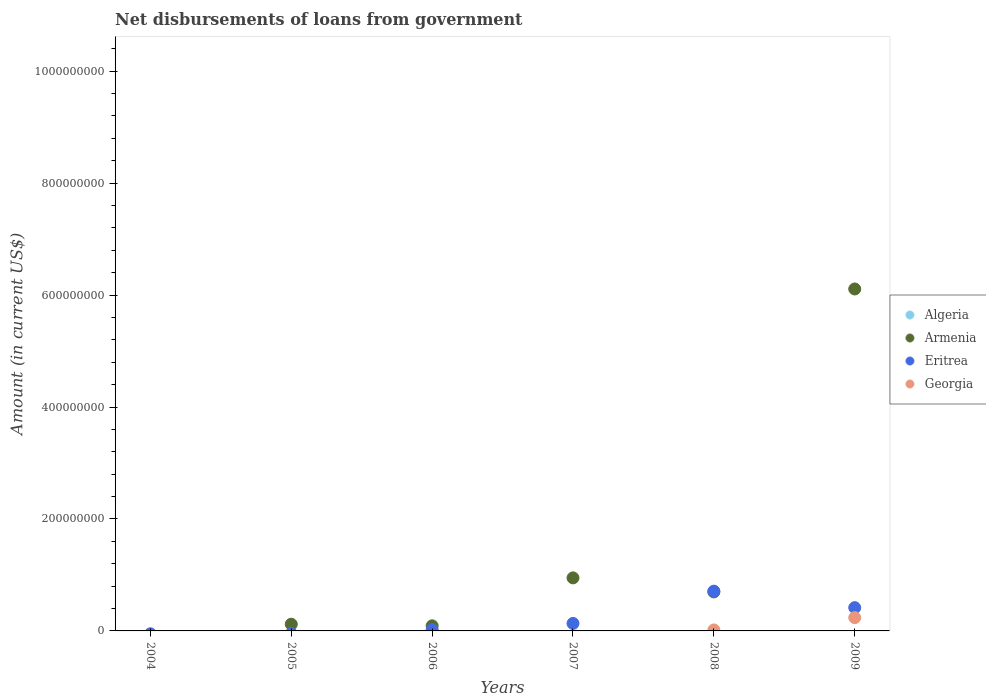What is the amount of loan disbursed from government in Armenia in 2005?
Your answer should be compact. 1.20e+07. Across all years, what is the maximum amount of loan disbursed from government in Georgia?
Provide a short and direct response. 2.37e+07. Across all years, what is the minimum amount of loan disbursed from government in Armenia?
Offer a terse response. 0. What is the total amount of loan disbursed from government in Georgia in the graph?
Keep it short and to the point. 2.55e+07. What is the difference between the amount of loan disbursed from government in Eritrea in 2007 and that in 2009?
Offer a very short reply. -2.82e+07. What is the difference between the amount of loan disbursed from government in Georgia in 2004 and the amount of loan disbursed from government in Algeria in 2007?
Provide a short and direct response. 0. What is the average amount of loan disbursed from government in Armenia per year?
Provide a short and direct response. 1.33e+08. In the year 2009, what is the difference between the amount of loan disbursed from government in Eritrea and amount of loan disbursed from government in Armenia?
Your response must be concise. -5.69e+08. In how many years, is the amount of loan disbursed from government in Armenia greater than 760000000 US$?
Your answer should be very brief. 0. What is the ratio of the amount of loan disbursed from government in Armenia in 2006 to that in 2007?
Your answer should be very brief. 0.1. Is the amount of loan disbursed from government in Eritrea in 2007 less than that in 2009?
Your response must be concise. Yes. Is the difference between the amount of loan disbursed from government in Eritrea in 2006 and 2008 greater than the difference between the amount of loan disbursed from government in Armenia in 2006 and 2008?
Your response must be concise. No. What is the difference between the highest and the second highest amount of loan disbursed from government in Armenia?
Make the answer very short. 5.16e+08. What is the difference between the highest and the lowest amount of loan disbursed from government in Eritrea?
Offer a very short reply. 7.10e+07. Is the sum of the amount of loan disbursed from government in Armenia in 2008 and 2009 greater than the maximum amount of loan disbursed from government in Georgia across all years?
Provide a succinct answer. Yes. Is it the case that in every year, the sum of the amount of loan disbursed from government in Eritrea and amount of loan disbursed from government in Armenia  is greater than the sum of amount of loan disbursed from government in Georgia and amount of loan disbursed from government in Algeria?
Provide a succinct answer. No. Is it the case that in every year, the sum of the amount of loan disbursed from government in Armenia and amount of loan disbursed from government in Georgia  is greater than the amount of loan disbursed from government in Algeria?
Make the answer very short. No. Does the amount of loan disbursed from government in Algeria monotonically increase over the years?
Give a very brief answer. No. Is the amount of loan disbursed from government in Armenia strictly less than the amount of loan disbursed from government in Georgia over the years?
Your answer should be compact. No. How many dotlines are there?
Offer a terse response. 3. How many years are there in the graph?
Your answer should be compact. 6. Does the graph contain any zero values?
Your answer should be very brief. Yes. Where does the legend appear in the graph?
Make the answer very short. Center right. How many legend labels are there?
Ensure brevity in your answer.  4. What is the title of the graph?
Your response must be concise. Net disbursements of loans from government. What is the label or title of the X-axis?
Provide a succinct answer. Years. What is the label or title of the Y-axis?
Offer a terse response. Amount (in current US$). What is the Amount (in current US$) in Algeria in 2004?
Give a very brief answer. 0. What is the Amount (in current US$) of Armenia in 2004?
Offer a very short reply. 0. What is the Amount (in current US$) in Georgia in 2004?
Your answer should be very brief. 0. What is the Amount (in current US$) of Armenia in 2005?
Offer a very short reply. 1.20e+07. What is the Amount (in current US$) of Georgia in 2005?
Your response must be concise. 0. What is the Amount (in current US$) of Algeria in 2006?
Provide a succinct answer. 0. What is the Amount (in current US$) in Armenia in 2006?
Offer a very short reply. 9.10e+06. What is the Amount (in current US$) in Eritrea in 2006?
Make the answer very short. 2.37e+06. What is the Amount (in current US$) of Armenia in 2007?
Ensure brevity in your answer.  9.48e+07. What is the Amount (in current US$) of Eritrea in 2007?
Provide a short and direct response. 1.34e+07. What is the Amount (in current US$) in Georgia in 2007?
Provide a short and direct response. 0. What is the Amount (in current US$) in Armenia in 2008?
Offer a terse response. 6.97e+07. What is the Amount (in current US$) in Eritrea in 2008?
Ensure brevity in your answer.  7.10e+07. What is the Amount (in current US$) of Georgia in 2008?
Your response must be concise. 1.75e+06. What is the Amount (in current US$) in Armenia in 2009?
Keep it short and to the point. 6.11e+08. What is the Amount (in current US$) in Eritrea in 2009?
Your answer should be compact. 4.16e+07. What is the Amount (in current US$) of Georgia in 2009?
Offer a terse response. 2.37e+07. Across all years, what is the maximum Amount (in current US$) in Armenia?
Provide a succinct answer. 6.11e+08. Across all years, what is the maximum Amount (in current US$) in Eritrea?
Offer a very short reply. 7.10e+07. Across all years, what is the maximum Amount (in current US$) in Georgia?
Your answer should be very brief. 2.37e+07. Across all years, what is the minimum Amount (in current US$) of Eritrea?
Your response must be concise. 0. Across all years, what is the minimum Amount (in current US$) in Georgia?
Your response must be concise. 0. What is the total Amount (in current US$) in Armenia in the graph?
Your answer should be very brief. 7.96e+08. What is the total Amount (in current US$) of Eritrea in the graph?
Provide a short and direct response. 1.28e+08. What is the total Amount (in current US$) of Georgia in the graph?
Offer a very short reply. 2.55e+07. What is the difference between the Amount (in current US$) in Armenia in 2005 and that in 2006?
Provide a short and direct response. 2.87e+06. What is the difference between the Amount (in current US$) of Armenia in 2005 and that in 2007?
Offer a very short reply. -8.28e+07. What is the difference between the Amount (in current US$) of Armenia in 2005 and that in 2008?
Give a very brief answer. -5.77e+07. What is the difference between the Amount (in current US$) in Armenia in 2005 and that in 2009?
Your response must be concise. -5.99e+08. What is the difference between the Amount (in current US$) in Armenia in 2006 and that in 2007?
Provide a succinct answer. -8.57e+07. What is the difference between the Amount (in current US$) of Eritrea in 2006 and that in 2007?
Ensure brevity in your answer.  -1.10e+07. What is the difference between the Amount (in current US$) in Armenia in 2006 and that in 2008?
Make the answer very short. -6.06e+07. What is the difference between the Amount (in current US$) of Eritrea in 2006 and that in 2008?
Offer a very short reply. -6.87e+07. What is the difference between the Amount (in current US$) of Armenia in 2006 and that in 2009?
Offer a very short reply. -6.02e+08. What is the difference between the Amount (in current US$) of Eritrea in 2006 and that in 2009?
Keep it short and to the point. -3.92e+07. What is the difference between the Amount (in current US$) of Armenia in 2007 and that in 2008?
Ensure brevity in your answer.  2.51e+07. What is the difference between the Amount (in current US$) of Eritrea in 2007 and that in 2008?
Keep it short and to the point. -5.76e+07. What is the difference between the Amount (in current US$) of Armenia in 2007 and that in 2009?
Keep it short and to the point. -5.16e+08. What is the difference between the Amount (in current US$) of Eritrea in 2007 and that in 2009?
Your response must be concise. -2.82e+07. What is the difference between the Amount (in current US$) in Armenia in 2008 and that in 2009?
Offer a very short reply. -5.41e+08. What is the difference between the Amount (in current US$) in Eritrea in 2008 and that in 2009?
Give a very brief answer. 2.95e+07. What is the difference between the Amount (in current US$) in Georgia in 2008 and that in 2009?
Your response must be concise. -2.20e+07. What is the difference between the Amount (in current US$) in Armenia in 2005 and the Amount (in current US$) in Eritrea in 2006?
Offer a terse response. 9.59e+06. What is the difference between the Amount (in current US$) of Armenia in 2005 and the Amount (in current US$) of Eritrea in 2007?
Provide a short and direct response. -1.44e+06. What is the difference between the Amount (in current US$) of Armenia in 2005 and the Amount (in current US$) of Eritrea in 2008?
Give a very brief answer. -5.91e+07. What is the difference between the Amount (in current US$) of Armenia in 2005 and the Amount (in current US$) of Georgia in 2008?
Keep it short and to the point. 1.02e+07. What is the difference between the Amount (in current US$) of Armenia in 2005 and the Amount (in current US$) of Eritrea in 2009?
Offer a terse response. -2.96e+07. What is the difference between the Amount (in current US$) in Armenia in 2005 and the Amount (in current US$) in Georgia in 2009?
Keep it short and to the point. -1.18e+07. What is the difference between the Amount (in current US$) in Armenia in 2006 and the Amount (in current US$) in Eritrea in 2007?
Offer a very short reply. -4.31e+06. What is the difference between the Amount (in current US$) in Armenia in 2006 and the Amount (in current US$) in Eritrea in 2008?
Your response must be concise. -6.19e+07. What is the difference between the Amount (in current US$) in Armenia in 2006 and the Amount (in current US$) in Georgia in 2008?
Make the answer very short. 7.34e+06. What is the difference between the Amount (in current US$) in Eritrea in 2006 and the Amount (in current US$) in Georgia in 2008?
Provide a succinct answer. 6.19e+05. What is the difference between the Amount (in current US$) in Armenia in 2006 and the Amount (in current US$) in Eritrea in 2009?
Provide a succinct answer. -3.25e+07. What is the difference between the Amount (in current US$) of Armenia in 2006 and the Amount (in current US$) of Georgia in 2009?
Give a very brief answer. -1.46e+07. What is the difference between the Amount (in current US$) of Eritrea in 2006 and the Amount (in current US$) of Georgia in 2009?
Ensure brevity in your answer.  -2.14e+07. What is the difference between the Amount (in current US$) in Armenia in 2007 and the Amount (in current US$) in Eritrea in 2008?
Your answer should be very brief. 2.38e+07. What is the difference between the Amount (in current US$) of Armenia in 2007 and the Amount (in current US$) of Georgia in 2008?
Provide a succinct answer. 9.30e+07. What is the difference between the Amount (in current US$) in Eritrea in 2007 and the Amount (in current US$) in Georgia in 2008?
Give a very brief answer. 1.16e+07. What is the difference between the Amount (in current US$) in Armenia in 2007 and the Amount (in current US$) in Eritrea in 2009?
Offer a terse response. 5.32e+07. What is the difference between the Amount (in current US$) of Armenia in 2007 and the Amount (in current US$) of Georgia in 2009?
Make the answer very short. 7.10e+07. What is the difference between the Amount (in current US$) of Eritrea in 2007 and the Amount (in current US$) of Georgia in 2009?
Your answer should be compact. -1.03e+07. What is the difference between the Amount (in current US$) of Armenia in 2008 and the Amount (in current US$) of Eritrea in 2009?
Provide a succinct answer. 2.81e+07. What is the difference between the Amount (in current US$) of Armenia in 2008 and the Amount (in current US$) of Georgia in 2009?
Provide a succinct answer. 4.60e+07. What is the difference between the Amount (in current US$) in Eritrea in 2008 and the Amount (in current US$) in Georgia in 2009?
Provide a short and direct response. 4.73e+07. What is the average Amount (in current US$) in Algeria per year?
Ensure brevity in your answer.  0. What is the average Amount (in current US$) of Armenia per year?
Offer a very short reply. 1.33e+08. What is the average Amount (in current US$) of Eritrea per year?
Provide a succinct answer. 2.14e+07. What is the average Amount (in current US$) of Georgia per year?
Keep it short and to the point. 4.25e+06. In the year 2006, what is the difference between the Amount (in current US$) in Armenia and Amount (in current US$) in Eritrea?
Keep it short and to the point. 6.72e+06. In the year 2007, what is the difference between the Amount (in current US$) in Armenia and Amount (in current US$) in Eritrea?
Ensure brevity in your answer.  8.14e+07. In the year 2008, what is the difference between the Amount (in current US$) of Armenia and Amount (in current US$) of Eritrea?
Provide a succinct answer. -1.33e+06. In the year 2008, what is the difference between the Amount (in current US$) of Armenia and Amount (in current US$) of Georgia?
Ensure brevity in your answer.  6.80e+07. In the year 2008, what is the difference between the Amount (in current US$) of Eritrea and Amount (in current US$) of Georgia?
Provide a short and direct response. 6.93e+07. In the year 2009, what is the difference between the Amount (in current US$) in Armenia and Amount (in current US$) in Eritrea?
Offer a very short reply. 5.69e+08. In the year 2009, what is the difference between the Amount (in current US$) in Armenia and Amount (in current US$) in Georgia?
Make the answer very short. 5.87e+08. In the year 2009, what is the difference between the Amount (in current US$) of Eritrea and Amount (in current US$) of Georgia?
Offer a terse response. 1.78e+07. What is the ratio of the Amount (in current US$) in Armenia in 2005 to that in 2006?
Your response must be concise. 1.32. What is the ratio of the Amount (in current US$) of Armenia in 2005 to that in 2007?
Your answer should be very brief. 0.13. What is the ratio of the Amount (in current US$) of Armenia in 2005 to that in 2008?
Give a very brief answer. 0.17. What is the ratio of the Amount (in current US$) in Armenia in 2005 to that in 2009?
Offer a terse response. 0.02. What is the ratio of the Amount (in current US$) in Armenia in 2006 to that in 2007?
Your answer should be very brief. 0.1. What is the ratio of the Amount (in current US$) in Eritrea in 2006 to that in 2007?
Provide a succinct answer. 0.18. What is the ratio of the Amount (in current US$) in Armenia in 2006 to that in 2008?
Offer a very short reply. 0.13. What is the ratio of the Amount (in current US$) of Eritrea in 2006 to that in 2008?
Your answer should be compact. 0.03. What is the ratio of the Amount (in current US$) of Armenia in 2006 to that in 2009?
Your response must be concise. 0.01. What is the ratio of the Amount (in current US$) of Eritrea in 2006 to that in 2009?
Your answer should be very brief. 0.06. What is the ratio of the Amount (in current US$) of Armenia in 2007 to that in 2008?
Your response must be concise. 1.36. What is the ratio of the Amount (in current US$) of Eritrea in 2007 to that in 2008?
Ensure brevity in your answer.  0.19. What is the ratio of the Amount (in current US$) in Armenia in 2007 to that in 2009?
Keep it short and to the point. 0.16. What is the ratio of the Amount (in current US$) in Eritrea in 2007 to that in 2009?
Provide a succinct answer. 0.32. What is the ratio of the Amount (in current US$) in Armenia in 2008 to that in 2009?
Your response must be concise. 0.11. What is the ratio of the Amount (in current US$) in Eritrea in 2008 to that in 2009?
Keep it short and to the point. 1.71. What is the ratio of the Amount (in current US$) of Georgia in 2008 to that in 2009?
Provide a short and direct response. 0.07. What is the difference between the highest and the second highest Amount (in current US$) in Armenia?
Provide a short and direct response. 5.16e+08. What is the difference between the highest and the second highest Amount (in current US$) of Eritrea?
Your answer should be compact. 2.95e+07. What is the difference between the highest and the lowest Amount (in current US$) of Armenia?
Provide a succinct answer. 6.11e+08. What is the difference between the highest and the lowest Amount (in current US$) of Eritrea?
Ensure brevity in your answer.  7.10e+07. What is the difference between the highest and the lowest Amount (in current US$) of Georgia?
Offer a terse response. 2.37e+07. 